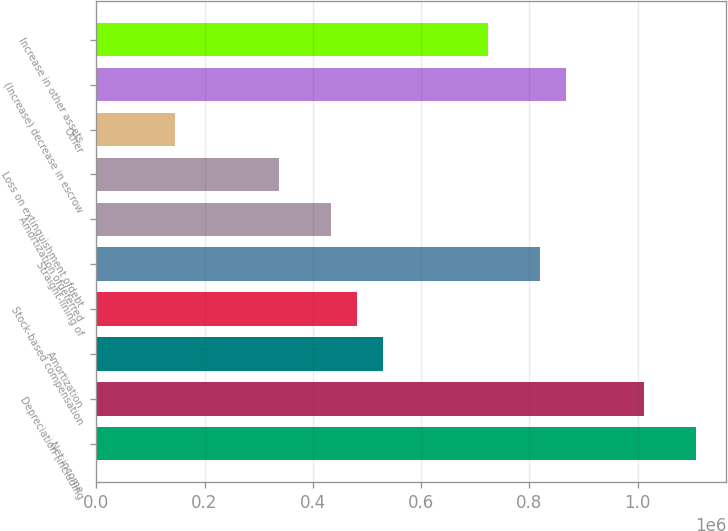Convert chart to OTSL. <chart><loc_0><loc_0><loc_500><loc_500><bar_chart><fcel>Net income<fcel>Depreciation (including<fcel>Amortization<fcel>Stock-based compensation<fcel>Straight-lining of<fcel>Amortization ofdeferred<fcel>Loss on extinguishment ofdebt<fcel>Other<fcel>(Increase) decrease in escrow<fcel>Increase in other assets<nl><fcel>1.10809e+06<fcel>1.01176e+06<fcel>530136<fcel>481974<fcel>819111<fcel>433812<fcel>337487<fcel>144837<fcel>867273<fcel>722786<nl></chart> 